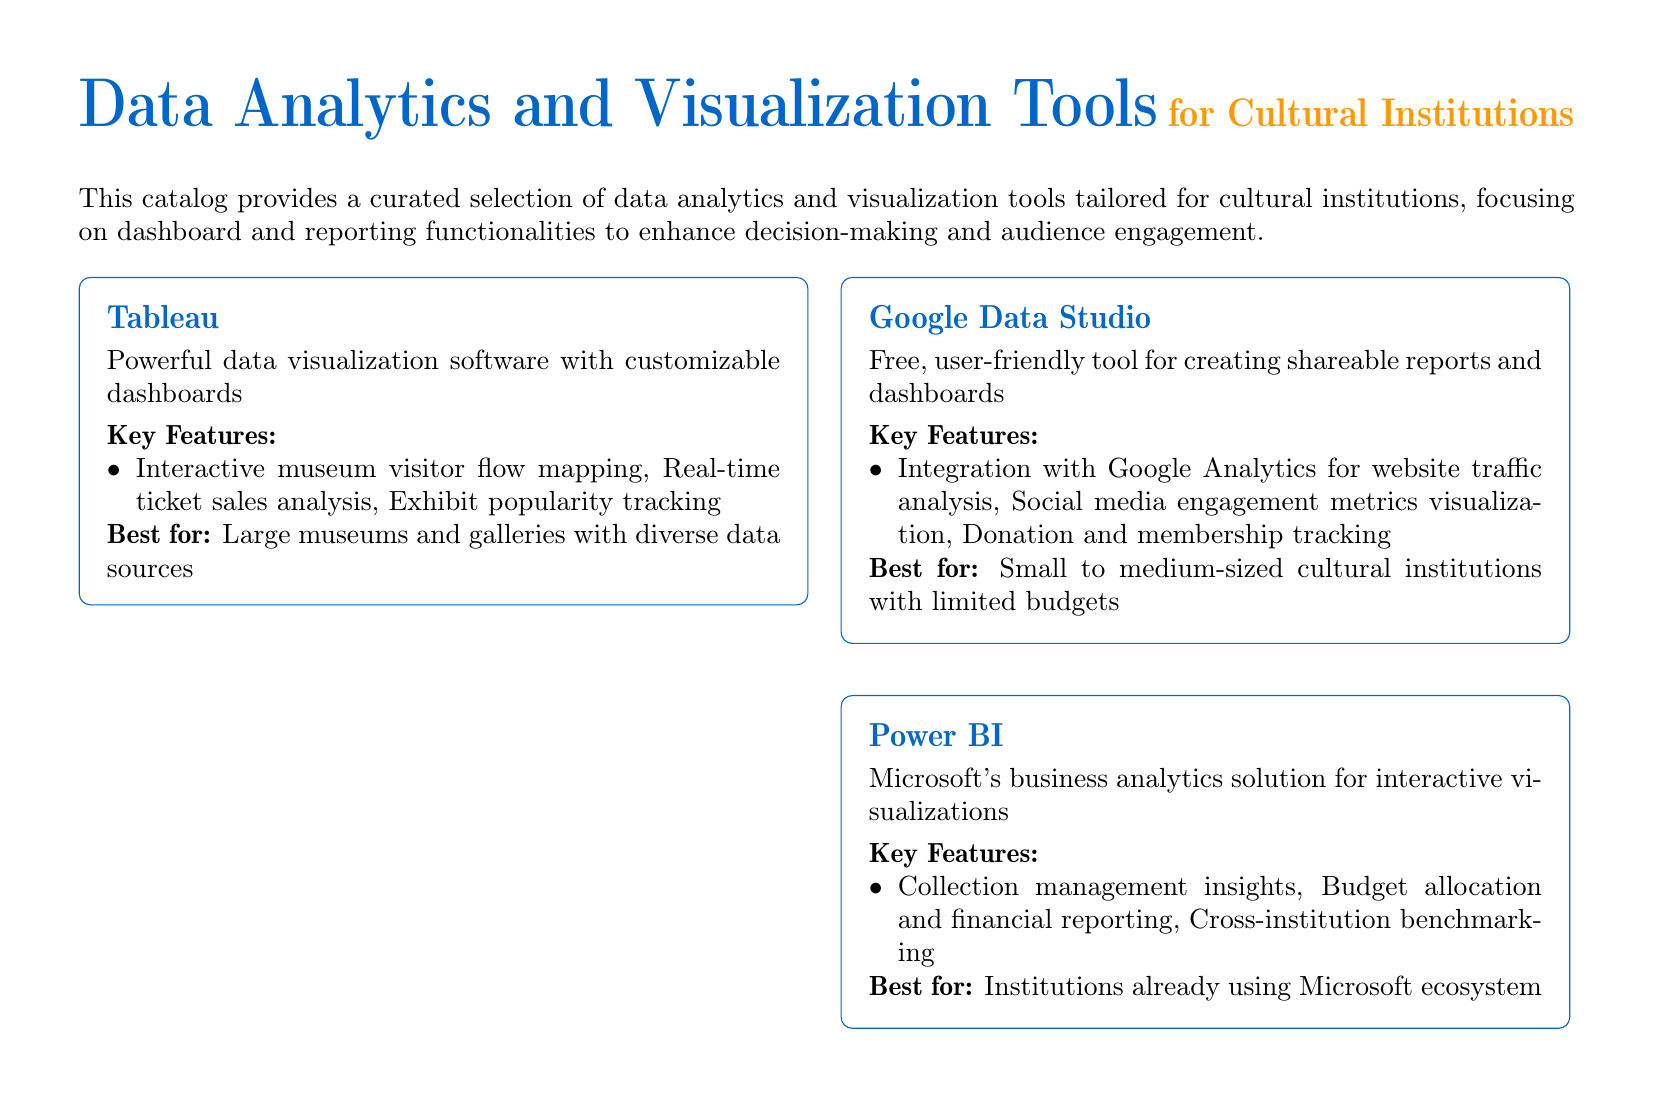What is the title of the document? The title is presented at the top of the document in a large font, specifying the focus on data analytics and visualization tools.
Answer: Data Analytics and Visualization Tools How many tools are listed in the catalog? The document lists a total of four tools in the catalog section.
Answer: Four Which tool is described as being cloud-based? The description in the section indicates that Domo is a cloud-based platform.
Answer: Domo What key feature is associated with Tableau? The document highlights interactive museum visitor flow mapping as a key feature of Tableau.
Answer: Interactive museum visitor flow mapping Best for which type of institutions is Google Data Studio recommended? The document states that Google Data Studio is best for small to medium-sized cultural institutions with limited budgets.
Answer: Small to medium-sized cultural institutions with limited budgets What’s a key feature of Domo? The document mentions predictive analytics for exhibition planning as a key feature of Domo.
Answer: Predictive analytics for exhibition planning Which tool is specifically mentioned to integrate with Google Analytics? The document explicitly states that Google Data Studio integrates with Google Analytics for website traffic analysis.
Answer: Google Data Studio What is the conclusion of the document focused on? The conclusion emphasizes the significant impact of selecting the right data analytics tool on understanding audiences and optimizing operations.
Answer: Selecting the right data analytics and visualization tool What type of institutions is Power BI best for? The document specifies that Power BI is best for institutions already using the Microsoft ecosystem.
Answer: Institutions already using Microsoft ecosystem 